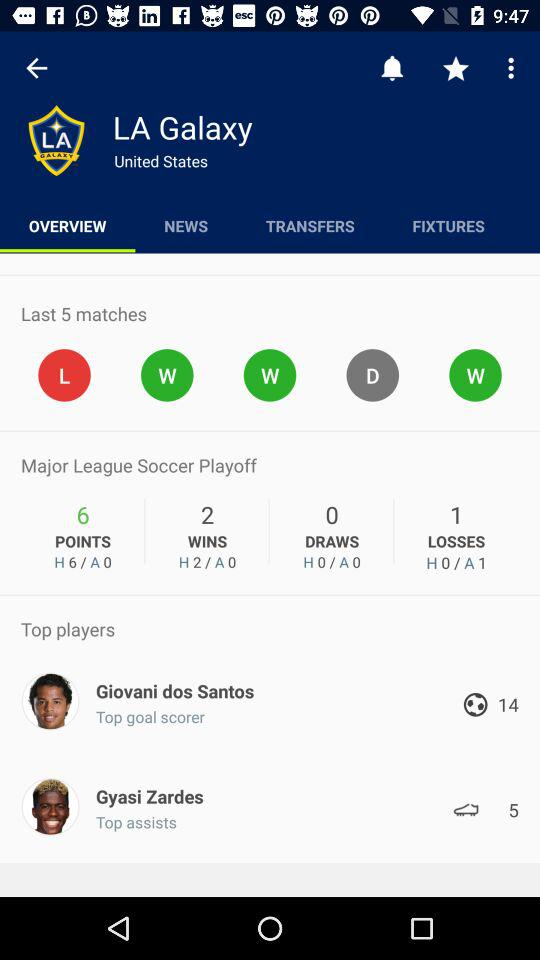How many goals has Gyasi Zardes scored?
Answer the question using a single word or phrase. 5 